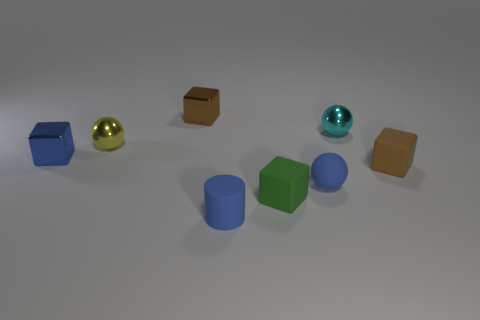Subtract 1 balls. How many balls are left? 2 Add 1 small brown matte objects. How many objects exist? 9 Subtract all metal balls. How many balls are left? 1 Subtract all red blocks. Subtract all purple cylinders. How many blocks are left? 4 Subtract all cylinders. How many objects are left? 7 Subtract all metallic things. Subtract all small yellow shiny spheres. How many objects are left? 3 Add 3 blue cylinders. How many blue cylinders are left? 4 Add 7 tiny brown matte objects. How many tiny brown matte objects exist? 8 Subtract 0 gray cylinders. How many objects are left? 8 